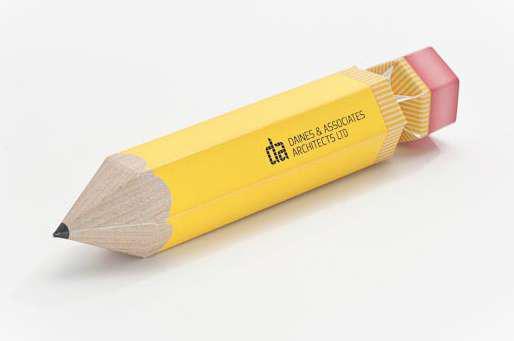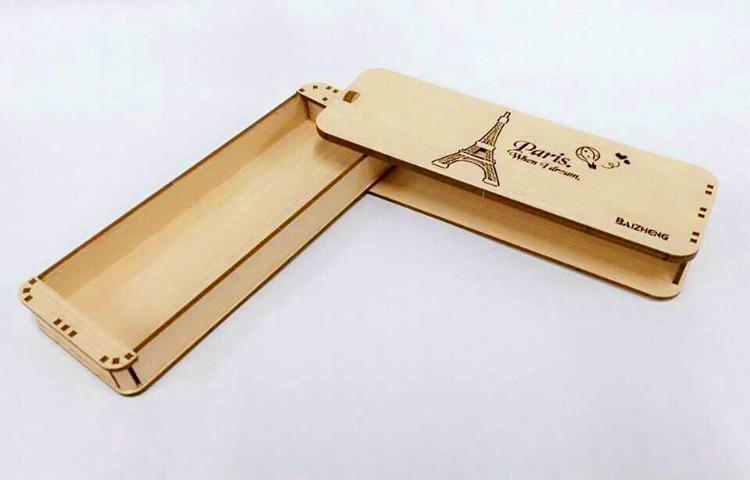The first image is the image on the left, the second image is the image on the right. For the images displayed, is the sentence "One of the pencil cases pictured has an Eiffel tower imprint." factually correct? Answer yes or no. Yes. The first image is the image on the left, the second image is the image on the right. For the images displayed, is the sentence "The case is open in the image on the lef." factually correct? Answer yes or no. No. 